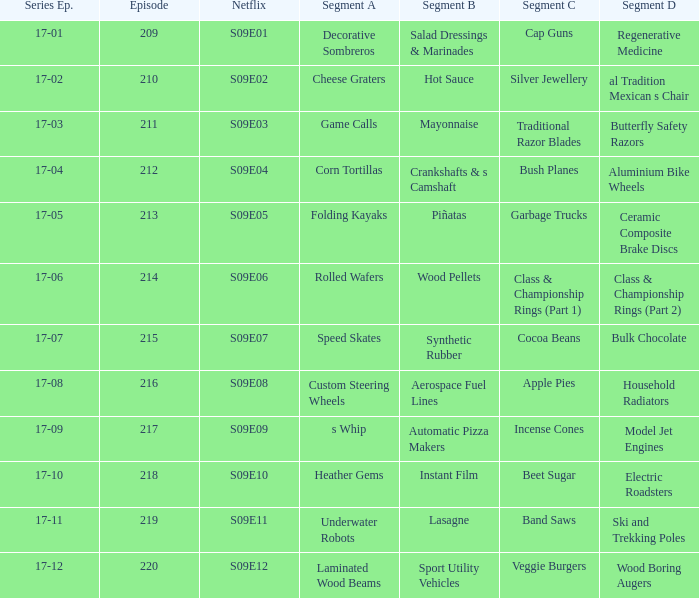How many segments involve wood boring augers Laminated Wood Beams. I'm looking to parse the entire table for insights. Could you assist me with that? {'header': ['Series Ep.', 'Episode', 'Netflix', 'Segment A', 'Segment B', 'Segment C', 'Segment D'], 'rows': [['17-01', '209', 'S09E01', 'Decorative Sombreros', 'Salad Dressings & Marinades', 'Cap Guns', 'Regenerative Medicine'], ['17-02', '210', 'S09E02', 'Cheese Graters', 'Hot Sauce', 'Silver Jewellery', 'al Tradition Mexican s Chair'], ['17-03', '211', 'S09E03', 'Game Calls', 'Mayonnaise', 'Traditional Razor Blades', 'Butterfly Safety Razors'], ['17-04', '212', 'S09E04', 'Corn Tortillas', 'Crankshafts & s Camshaft', 'Bush Planes', 'Aluminium Bike Wheels'], ['17-05', '213', 'S09E05', 'Folding Kayaks', 'Piñatas', 'Garbage Trucks', 'Ceramic Composite Brake Discs'], ['17-06', '214', 'S09E06', 'Rolled Wafers', 'Wood Pellets', 'Class & Championship Rings (Part 1)', 'Class & Championship Rings (Part 2)'], ['17-07', '215', 'S09E07', 'Speed Skates', 'Synthetic Rubber', 'Cocoa Beans', 'Bulk Chocolate'], ['17-08', '216', 'S09E08', 'Custom Steering Wheels', 'Aerospace Fuel Lines', 'Apple Pies', 'Household Radiators'], ['17-09', '217', 'S09E09', 's Whip', 'Automatic Pizza Makers', 'Incense Cones', 'Model Jet Engines'], ['17-10', '218', 'S09E10', 'Heather Gems', 'Instant Film', 'Beet Sugar', 'Electric Roadsters'], ['17-11', '219', 'S09E11', 'Underwater Robots', 'Lasagne', 'Band Saws', 'Ski and Trekking Poles'], ['17-12', '220', 'S09E12', 'Laminated Wood Beams', 'Sport Utility Vehicles', 'Veggie Burgers', 'Wood Boring Augers']]} 